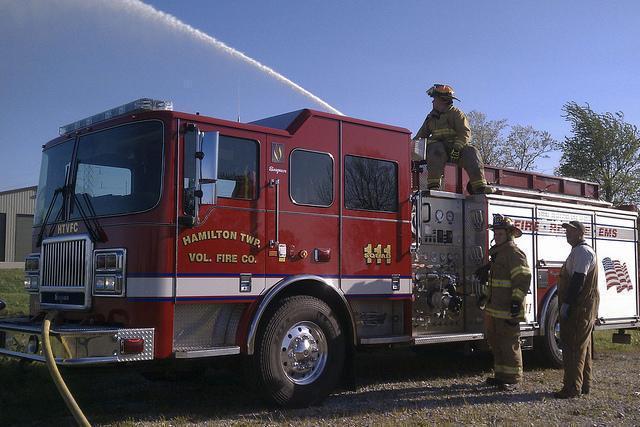What province does this fire crew reside in?
From the following four choices, select the correct answer to address the question.
Options: Alberta, nwt, ontario, pei. Ontario. 